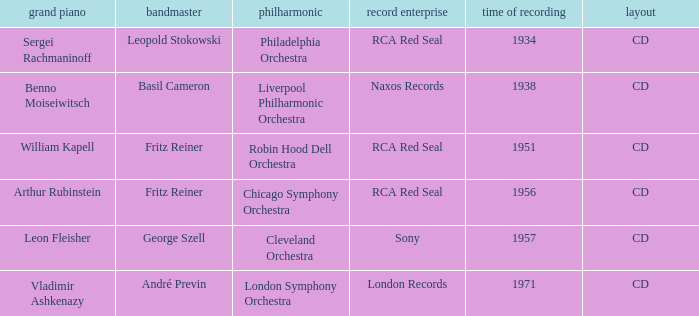Parse the full table. {'header': ['grand piano', 'bandmaster', 'philharmonic', 'record enterprise', 'time of recording', 'layout'], 'rows': [['Sergei Rachmaninoff', 'Leopold Stokowski', 'Philadelphia Orchestra', 'RCA Red Seal', '1934', 'CD'], ['Benno Moiseiwitsch', 'Basil Cameron', 'Liverpool Philharmonic Orchestra', 'Naxos Records', '1938', 'CD'], ['William Kapell', 'Fritz Reiner', 'Robin Hood Dell Orchestra', 'RCA Red Seal', '1951', 'CD'], ['Arthur Rubinstein', 'Fritz Reiner', 'Chicago Symphony Orchestra', 'RCA Red Seal', '1956', 'CD'], ['Leon Fleisher', 'George Szell', 'Cleveland Orchestra', 'Sony', '1957', 'CD'], ['Vladimir Ashkenazy', 'André Previn', 'London Symphony Orchestra', 'London Records', '1971', 'CD']]} Which orchestra has a recording year of 1951? Robin Hood Dell Orchestra. 